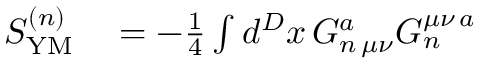Convert formula to latex. <formula><loc_0><loc_0><loc_500><loc_500>\begin{array} { r l } { S _ { Y M } ^ { ( n ) } } & = - \frac { 1 } { 4 } \int d ^ { D } x \, G _ { n \, \mu \nu } ^ { a } G _ { n } ^ { \mu \nu \, a } } \end{array}</formula> 